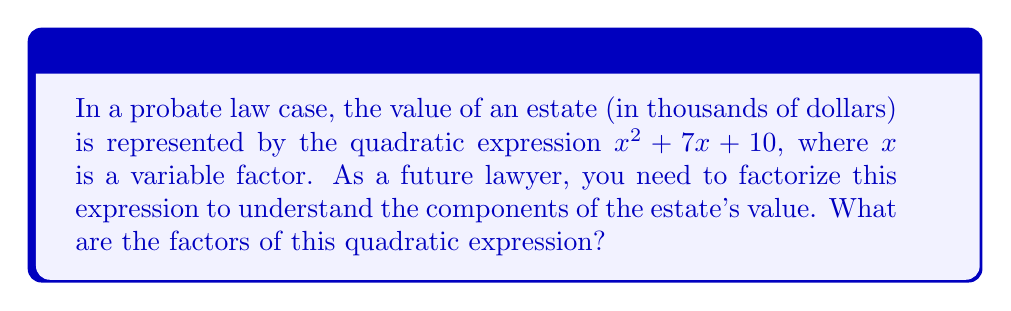Can you answer this question? To factorize the quadratic expression $x^2 + 7x + 10$, we'll follow these steps:

1) First, we identify that this is a quadratic expression in the form $ax^2 + bx + c$, where $a=1$, $b=7$, and $c=10$.

2) We need to find two numbers that multiply to give $ac$ (which is $1 \times 10 = 10$) and add up to $b$ (which is 7).

3) The two numbers that satisfy this condition are 5 and 2, because $5 \times 2 = 10$ and $5 + 2 = 7$.

4) We can rewrite the middle term using these numbers:
   $x^2 + 7x + 10 = x^2 + 5x + 2x + 10$

5) Now we can group the terms:
   $(x^2 + 5x) + (2x + 10)$

6) Factor out the common factors from each group:
   $x(x + 5) + 2(x + 5)$

7) We can now factor out the common binomial $(x + 5)$:
   $(x + 5)(x + 2)$

Therefore, the factored form of $x^2 + 7x + 10$ is $(x + 5)(x + 2)$.
Answer: $(x + 5)(x + 2)$ 